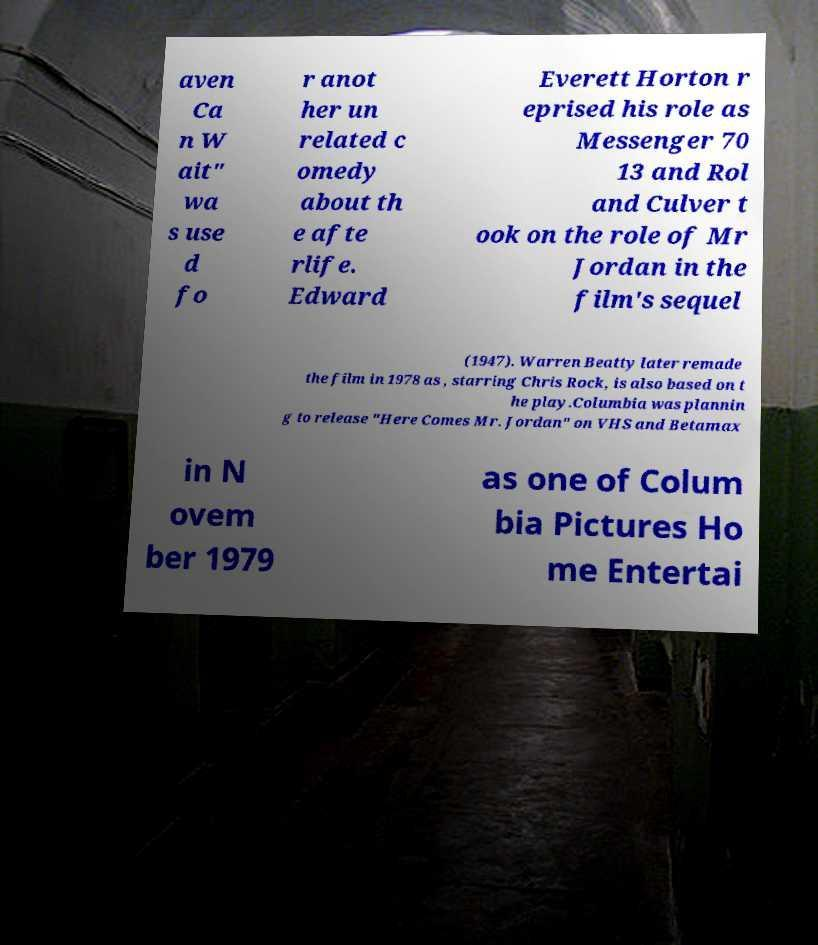Could you extract and type out the text from this image? aven Ca n W ait" wa s use d fo r anot her un related c omedy about th e afte rlife. Edward Everett Horton r eprised his role as Messenger 70 13 and Rol and Culver t ook on the role of Mr Jordan in the film's sequel (1947). Warren Beatty later remade the film in 1978 as , starring Chris Rock, is also based on t he play.Columbia was plannin g to release "Here Comes Mr. Jordan" on VHS and Betamax in N ovem ber 1979 as one of Colum bia Pictures Ho me Entertai 